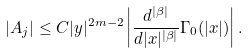<formula> <loc_0><loc_0><loc_500><loc_500>| A _ { j } | \leq C | y | ^ { 2 m - 2 } \left | \frac { d ^ { | \beta | } } { d | x | ^ { | \beta | } } \Gamma _ { 0 } ( | x | ) \right | .</formula> 